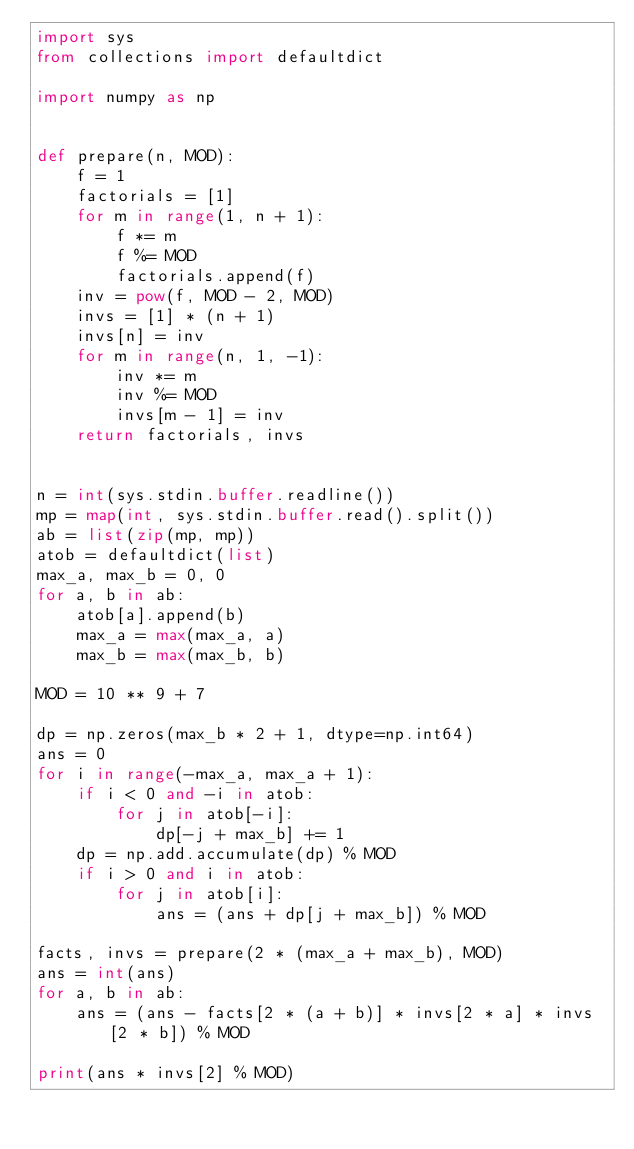<code> <loc_0><loc_0><loc_500><loc_500><_Python_>import sys
from collections import defaultdict

import numpy as np


def prepare(n, MOD):
    f = 1
    factorials = [1]
    for m in range(1, n + 1):
        f *= m
        f %= MOD
        factorials.append(f)
    inv = pow(f, MOD - 2, MOD)
    invs = [1] * (n + 1)
    invs[n] = inv
    for m in range(n, 1, -1):
        inv *= m
        inv %= MOD
        invs[m - 1] = inv
    return factorials, invs


n = int(sys.stdin.buffer.readline())
mp = map(int, sys.stdin.buffer.read().split())
ab = list(zip(mp, mp))
atob = defaultdict(list)
max_a, max_b = 0, 0
for a, b in ab:
    atob[a].append(b)
    max_a = max(max_a, a)
    max_b = max(max_b, b)

MOD = 10 ** 9 + 7

dp = np.zeros(max_b * 2 + 1, dtype=np.int64)
ans = 0
for i in range(-max_a, max_a + 1):
    if i < 0 and -i in atob:
        for j in atob[-i]:
            dp[-j + max_b] += 1
    dp = np.add.accumulate(dp) % MOD
    if i > 0 and i in atob:
        for j in atob[i]:
            ans = (ans + dp[j + max_b]) % MOD

facts, invs = prepare(2 * (max_a + max_b), MOD)
ans = int(ans)
for a, b in ab:
    ans = (ans - facts[2 * (a + b)] * invs[2 * a] * invs[2 * b]) % MOD

print(ans * invs[2] % MOD)
</code> 